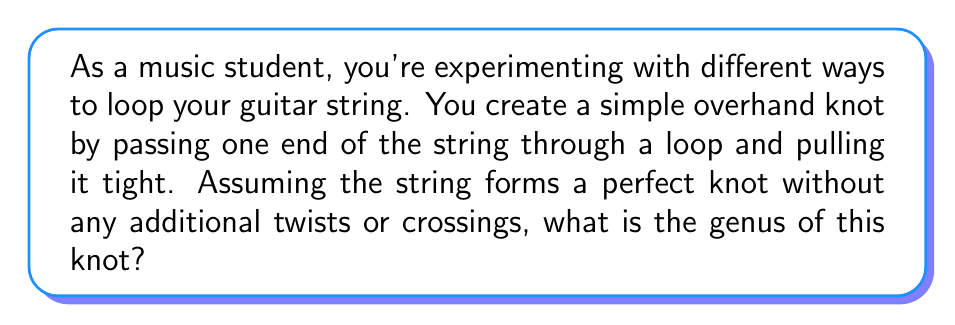Give your solution to this math problem. To determine the genus of a knot, we need to follow these steps:

1. Identify the knot: The described knot is known as the trefoil knot, which is the simplest non-trivial knot.

2. Understand genus: The genus of a knot is the minimum number of holes in a surface that the knot can be embedded on without self-intersection.

3. Apply the formula: For alternating knots (which includes the trefoil), we can use the formula:

   $$g = \frac{c - s + 2}{2}$$

   Where:
   $g$ = genus
   $c$ = number of crossings
   $s$ = number of Seifert circles

4. Count crossings: The trefoil knot has 3 crossings, so $c = 3$.

5. Determine Seifert circles: The trefoil knot has 2 Seifert circles.

6. Calculate:
   $$g = \frac{3 - 2 + 2}{2} = \frac{3}{2} = 1$$

Therefore, the genus of the trefoil knot is 1.
Answer: 1 